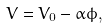<formula> <loc_0><loc_0><loc_500><loc_500>V = V _ { 0 } - \alpha \phi ,</formula> 